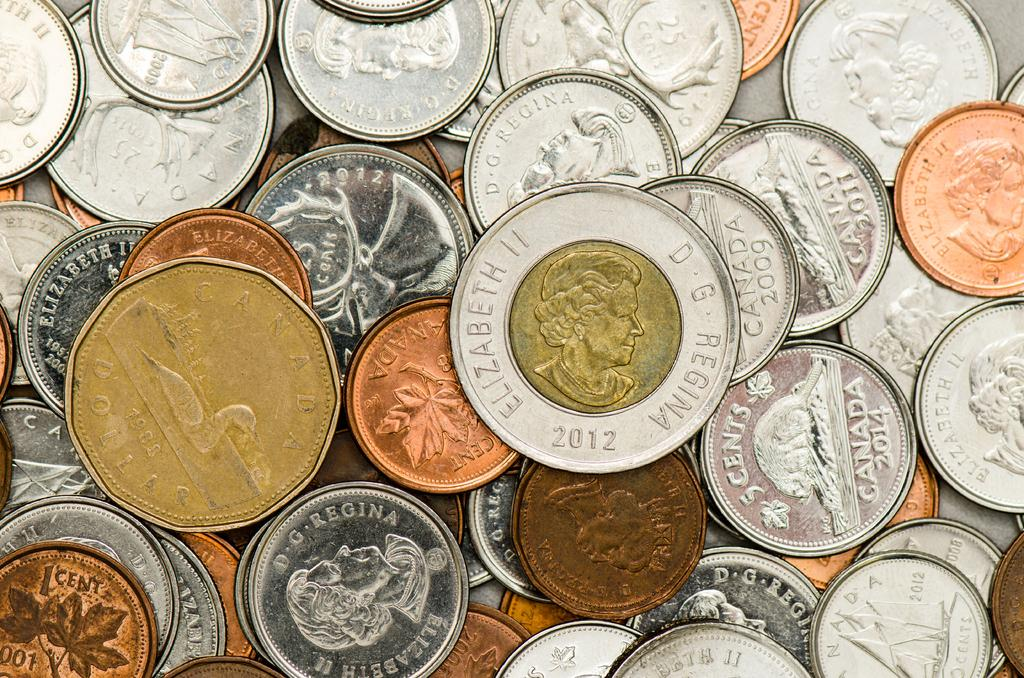<image>
Relay a brief, clear account of the picture shown. Some coins in a pile with one reading Elizabeth II. 